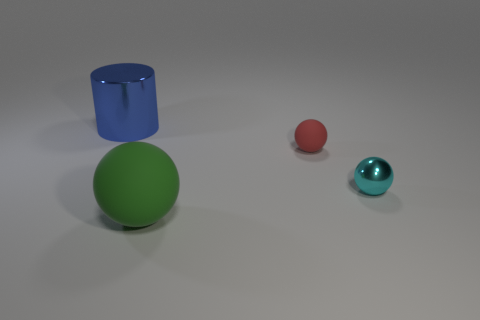Can you describe the lighting of the scene? The scene is evenly lit with a soft, diffused light source, creating gentle shadows on the ground beneath each object. This suggests an artificial light source, likely positioned above the objects to mimic an ambient lighting environment. 